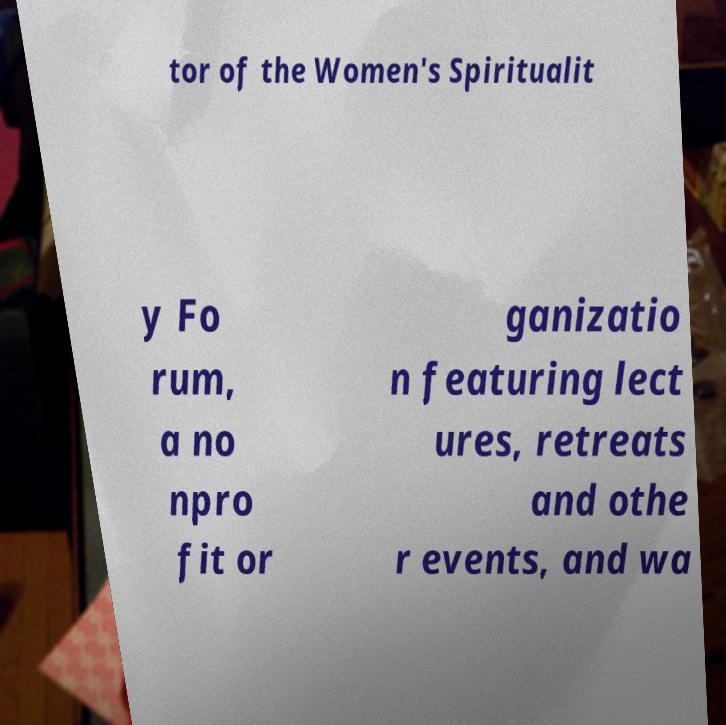I need the written content from this picture converted into text. Can you do that? tor of the Women's Spiritualit y Fo rum, a no npro fit or ganizatio n featuring lect ures, retreats and othe r events, and wa 